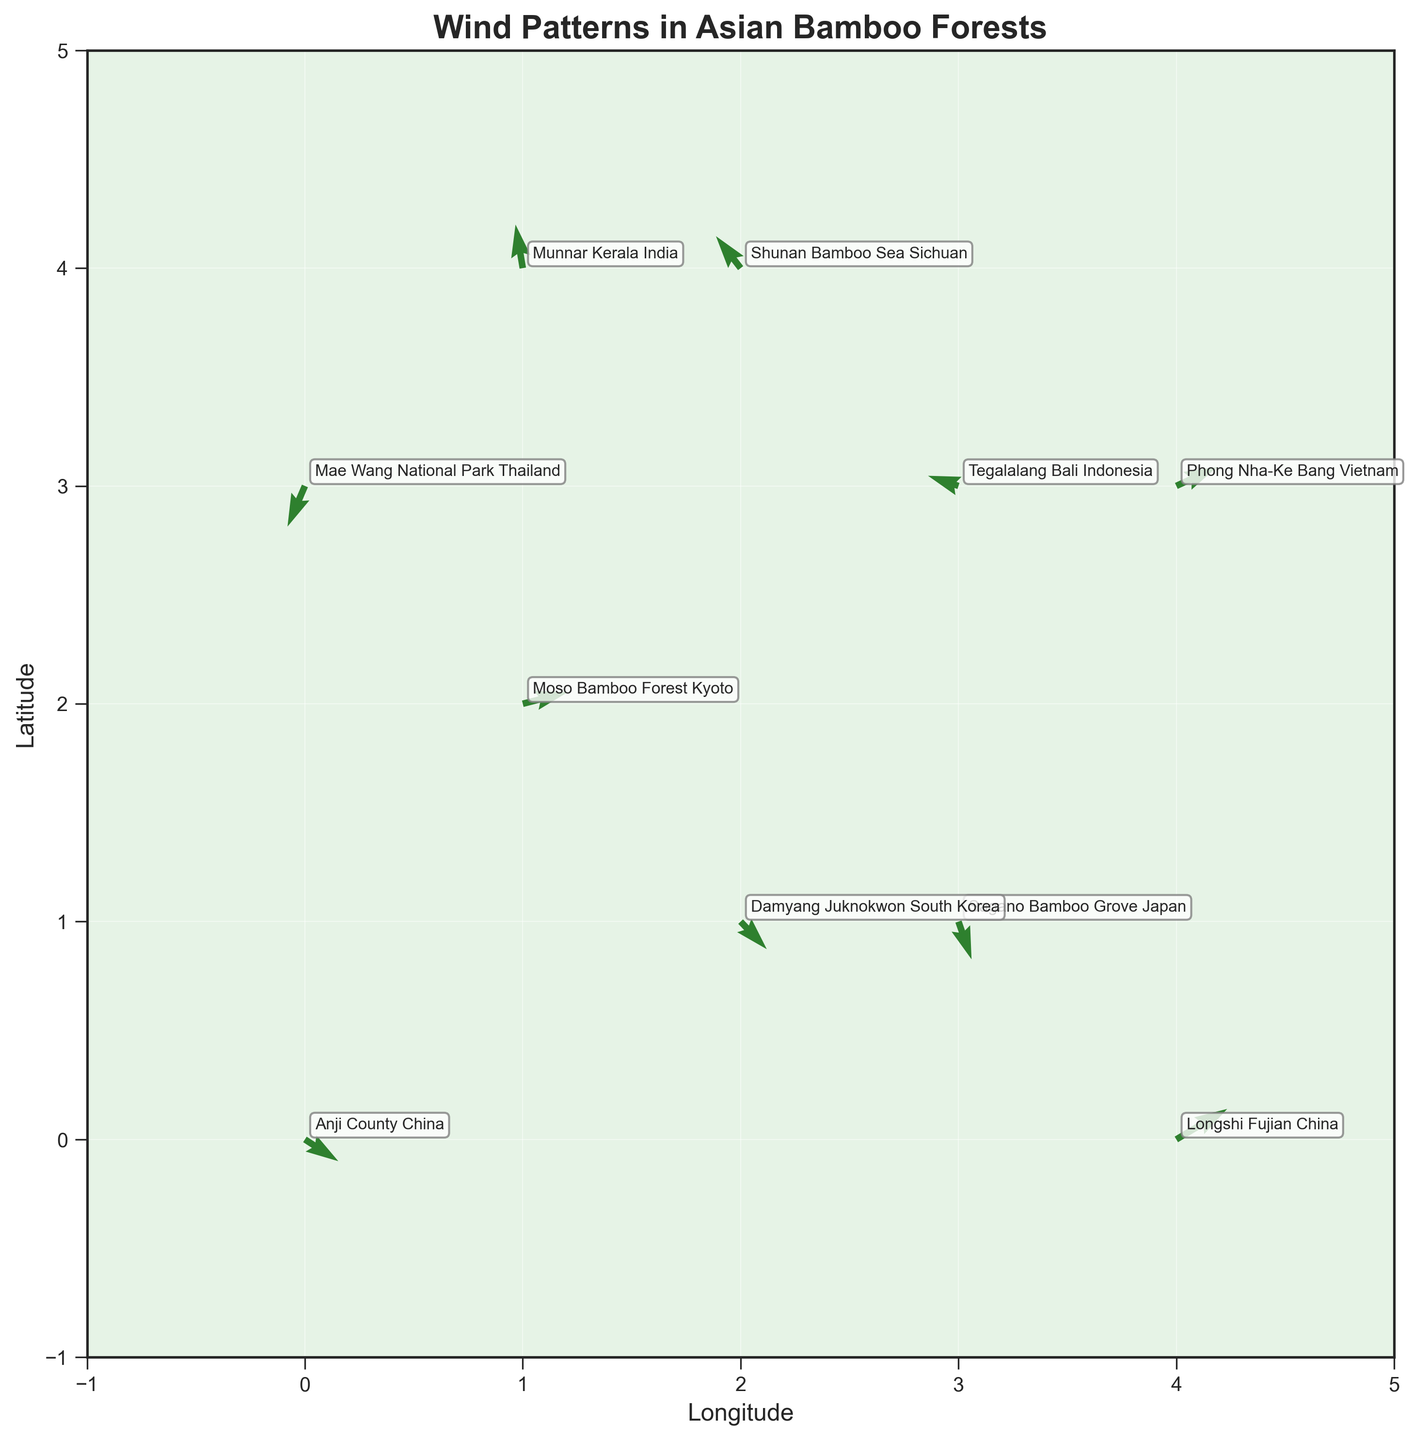What is the title of the plot? The title of the plot is located at the top center and indicates the main subject of the figure.
Answer: Wind Patterns in Asian Bamboo Forests What are the labels on the x and y axes? The x-axis label represents longitude and the y-axis label represents latitude. These labels are found next to the respective axes.
Answer: Longitude, Latitude How many data points are shown in the plot? Each arrow represents a data point. By counting the arrows, which are annotated with location names, we can determine the number of data points.
Answer: 10 Which location has the highest wind speed in a positive x-direction? The location with the highest u-value in the data represents the highest positive wind speed in the x-direction. By reviewing the plot and annotations, we find the arrow with the longest horizontal component pointing right.
Answer: Longshi Fujian China What is the average wind speed in the y-direction across all locations? To find the average, sum the v-values of all data points and divide by the number of points. v-values are: -1.5, 0.8, 2.2, -2.6, 1.3, 3.0, -1.9, 0.7, 2.1, -2.8. Sum = 1.3, Count = 10, Average = 1.3 / 10
Answer: 0.13 Which location experiences the strongest wind in a negative y-direction? The location with the most negative v-value indicates the strongest downward wind. By identifying the most negative v-value from the plot, we determine the location.
Answer: Sagano Bamboo Grove Japan Which two locations experience wind patterns in opposite directions? Wind patterns are given by the direction of arrows (u and v components). To find opposite directions, locate pairs where one has (u, v) and the other (-u, -v). Notably, "Shunan Bamboo Sea Sichuan" has (u = -1.7, v = 2.2) and "Longshi Fujian China" with(u = 3.5, v = 2.1) have vectors pointing in reverse directions.
Answer: Shunan Bamboo Sea Sichuan and Longshi Fujian China What is the general direction of the wind in Munnar, Kerala, India? By observing the arrow originating from Munnar's coordinates, the wind components are (u = -0.5, v = 3.0). This results in a northeast direction.
Answer: Northeast Which location has the closest wind pattern to the "neutral" or zero wind speed? The closest wind pattern to zero has the smallest magnitude of the vector (u, v). Calculate the magnitude \(\sqrt{u^2 + v^2}\) for each location and identify the smallest. Moso Bamboo Forest Kyoto (u=3.1, v=0.8): \(\sqrt{3.1^2 + 0.8^2} = 3.20\), Damyang Juknokwon South Korea (u=1.8, v=-1.9): \(\sqrt{1.8^2 + (-1.9)^2} = 2.61\). Smaller value indicates the smallest wind.
Answer: Damyang Juknokwon South Korea 